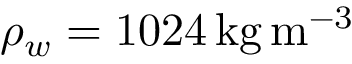Convert formula to latex. <formula><loc_0><loc_0><loc_500><loc_500>\rho _ { w } = 1 0 2 4 \, { k g \, m ^ { - 3 } }</formula> 